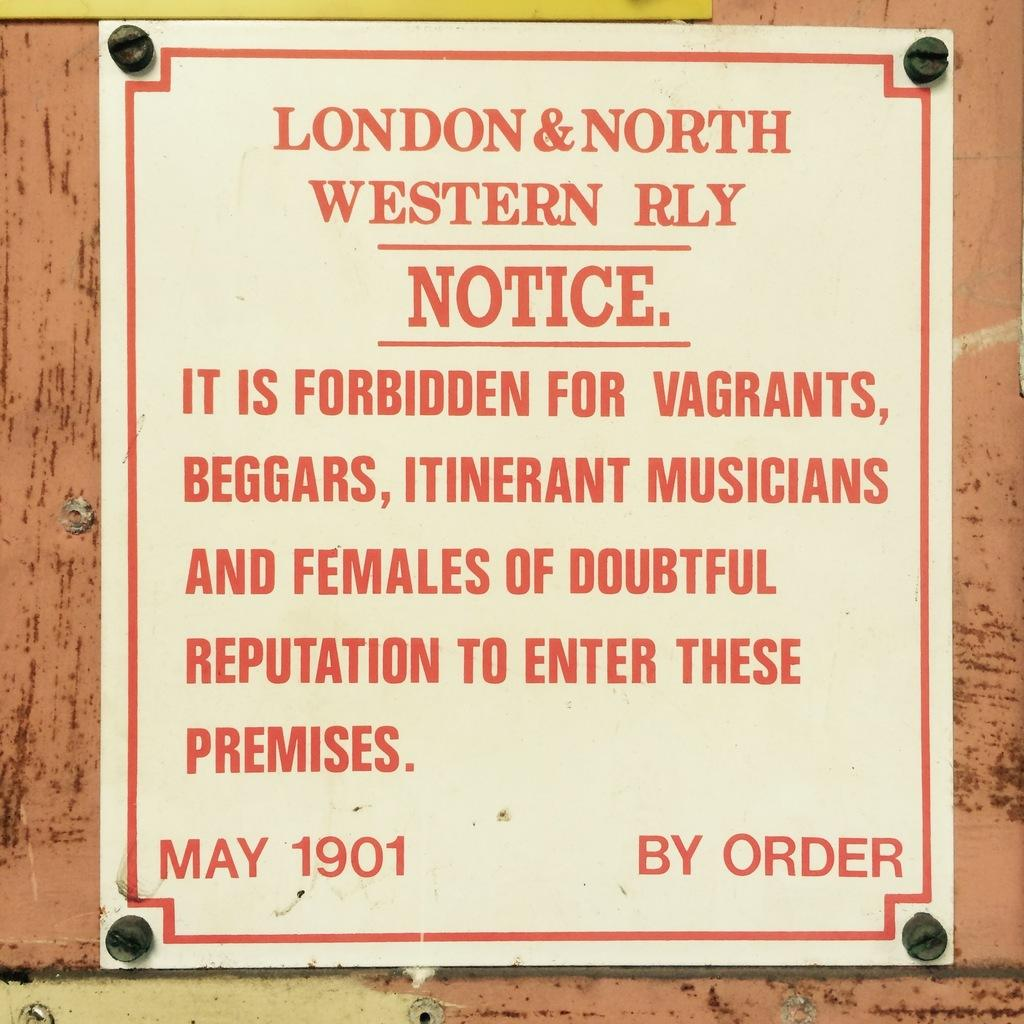<image>
Offer a succinct explanation of the picture presented. A sign from 1901 warns certain groups to keep out. 